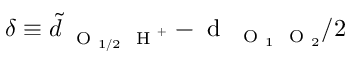<formula> <loc_0><loc_0><loc_500><loc_500>\delta \equiv \tilde { d } _ { O _ { 1 / 2 } H ^ { + } } - d _ { O _ { 1 } O _ { 2 } } / 2</formula> 